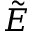Convert formula to latex. <formula><loc_0><loc_0><loc_500><loc_500>\tilde { E }</formula> 